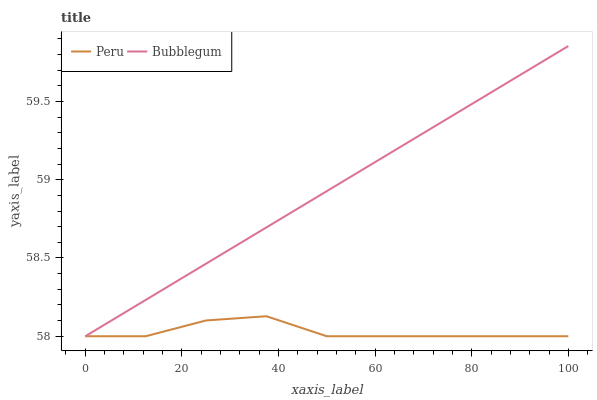Does Peru have the minimum area under the curve?
Answer yes or no. Yes. Does Bubblegum have the maximum area under the curve?
Answer yes or no. Yes. Does Peru have the maximum area under the curve?
Answer yes or no. No. Is Bubblegum the smoothest?
Answer yes or no. Yes. Is Peru the roughest?
Answer yes or no. Yes. Is Peru the smoothest?
Answer yes or no. No. Does Bubblegum have the lowest value?
Answer yes or no. Yes. Does Bubblegum have the highest value?
Answer yes or no. Yes. Does Peru have the highest value?
Answer yes or no. No. Does Bubblegum intersect Peru?
Answer yes or no. Yes. Is Bubblegum less than Peru?
Answer yes or no. No. Is Bubblegum greater than Peru?
Answer yes or no. No. 